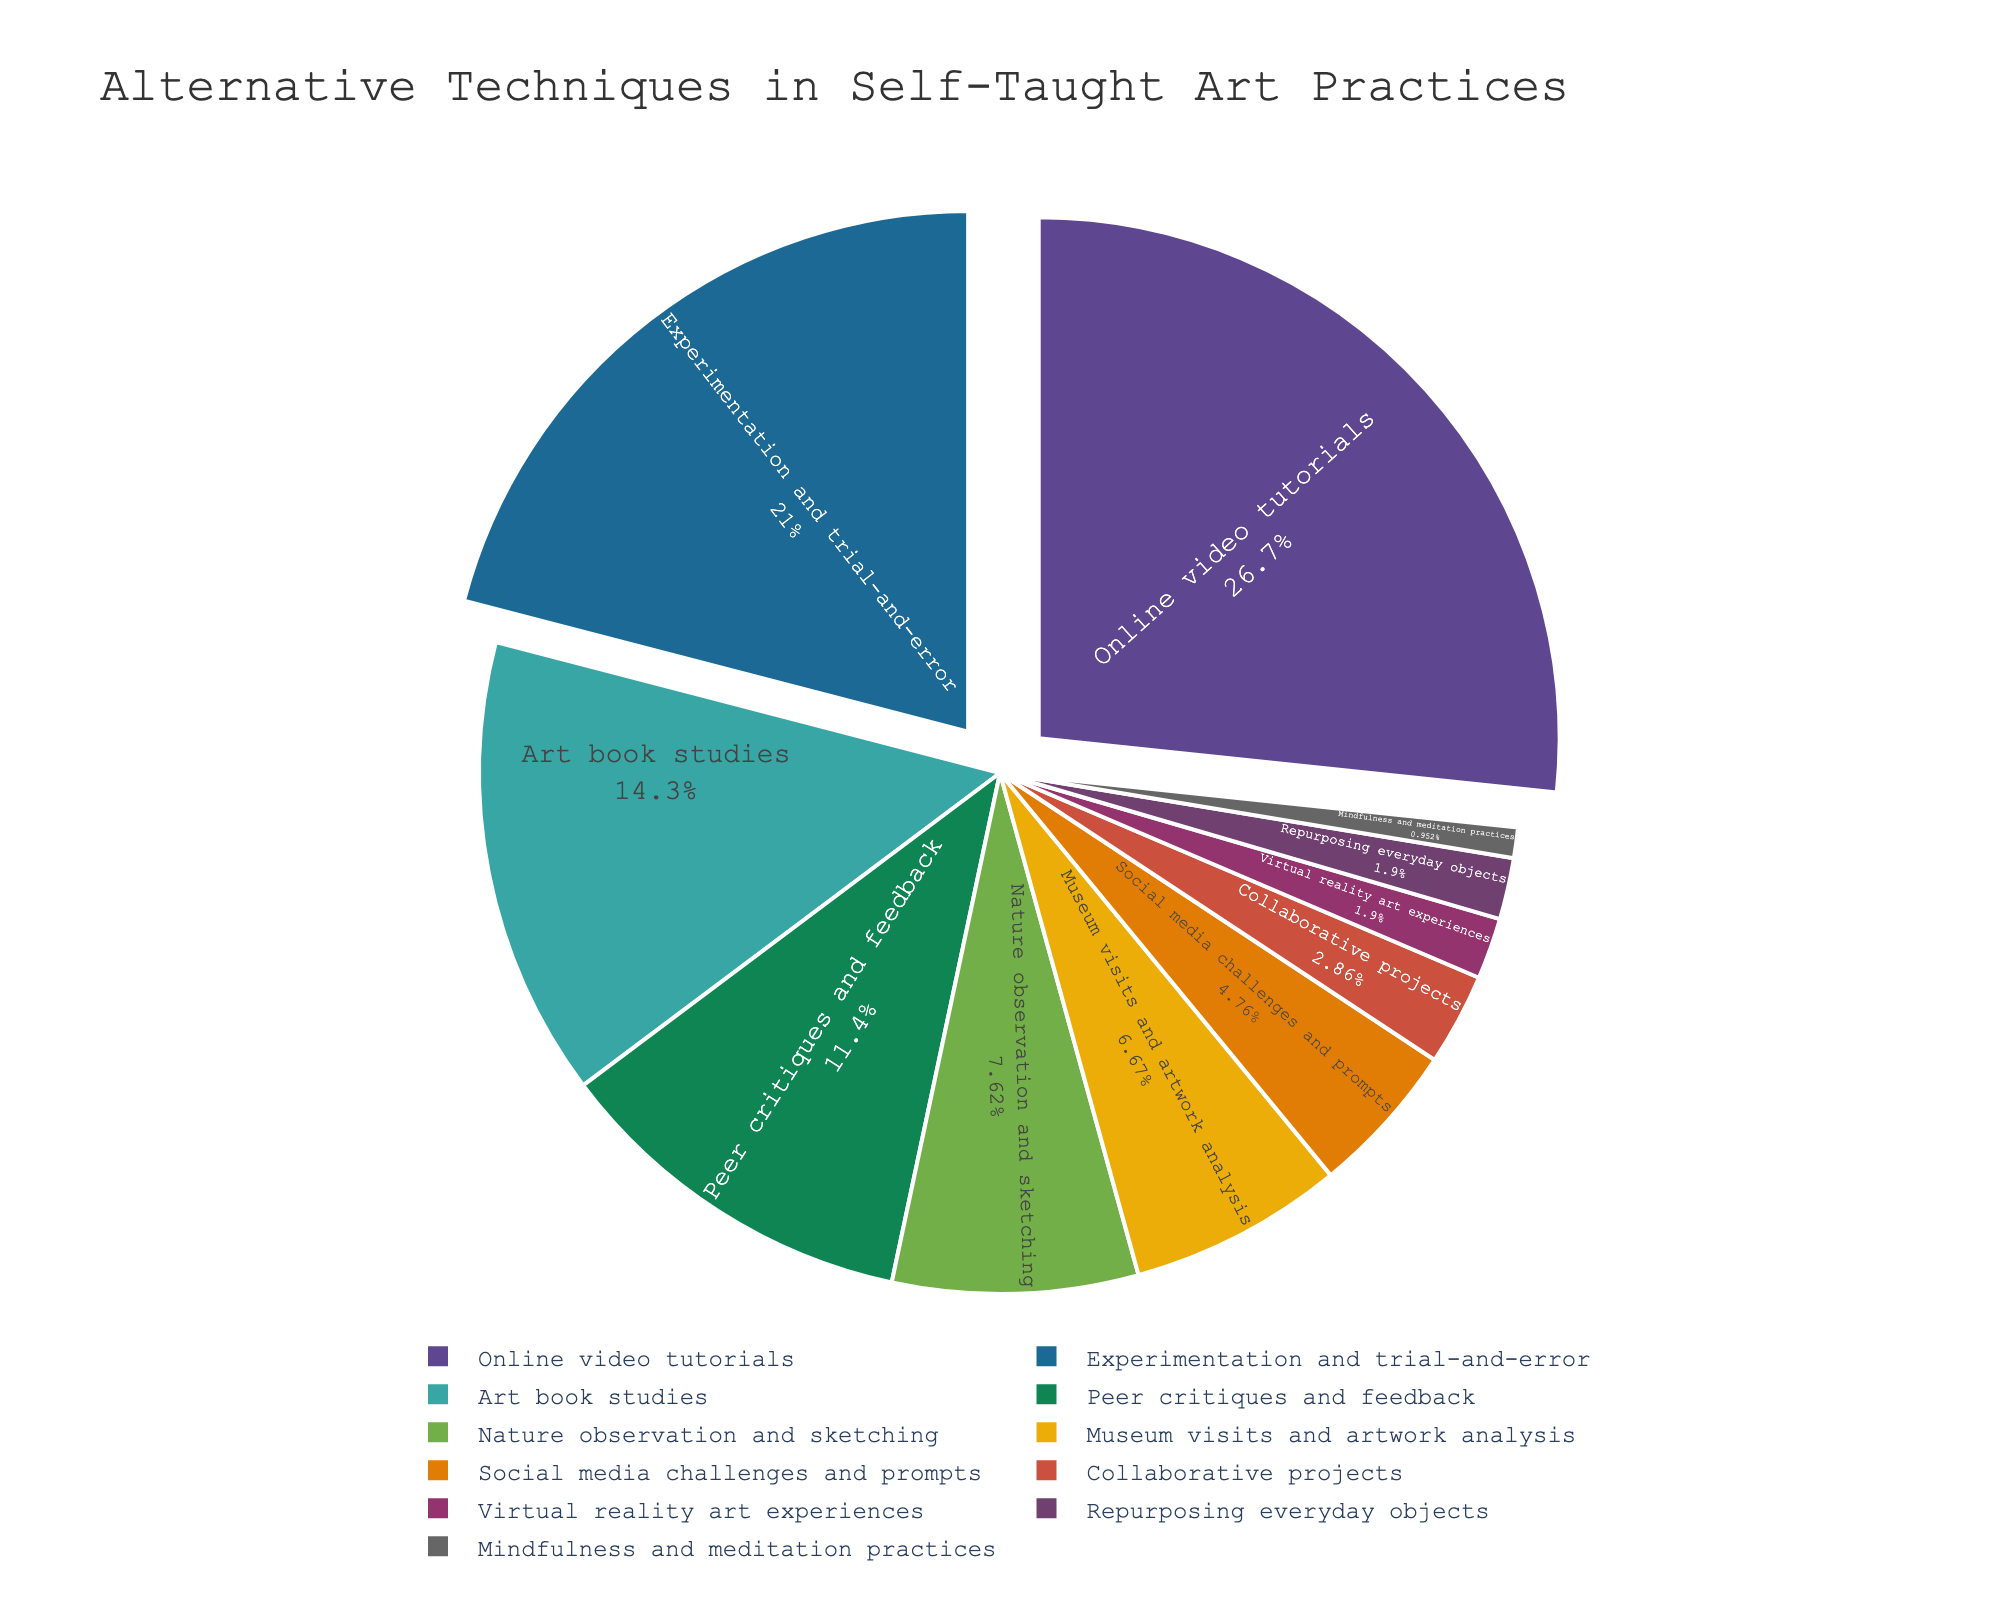what is the total percentage wrapped up by "Collaborative projects", "Virtual reality art experiences", and "Repurposing everyday objects"? Add the percentages of the three techniques: Collaborative projects (3%), Virtual reality art experiences (2%), and Repurposing everyday objects (2%). Therefore, the total percentage is 3 + 2 + 2 = 7%.
Answer: 7% Are there more percentages allocated to "Art book studies" or "Peer critiques and feedback"? Compare the percentages: Art book studies have 15%, while Peer critiques and feedback have 12%. Therefore, Art book studies have a higher percentage.
Answer: Art book studies What is the difference in percentages between "Nature observation and sketching" and "Museum visits and artwork analysis"? To find the difference, subtract the percentage of Museum visits and artwork analysis (7%) from Nature observation and sketching (8%). Thus, 8 - 7 = 1%.
Answer: 1% Which technique occupies the largest segment, and what is its percentage? The largest segment in the pie chart corresponds to Online video tutorials, which has a percentage of 28%.
Answer: Online video tutorials (28%) How much more popular are "Online video tutorials" compared to "Social media challenges and prompts"? Subtract the percentage of Social media challenges and prompts (5%) from Online video tutorials (28%). Therefore, 28 - 5 = 23%.
Answer: 23% What is the combined percentage of the top two techniques? The top two techniques are Online video tutorials (28%) and Experimentation and trial-and-error (22%). Add these percentages together to find the combined percentage: 28 + 22 = 50%.
Answer: 50% Which technique has the smallest percentage, and how much is it? The technique with the smallest percentage is Mindfulness and meditation practices, which has a percentage of 1%.
Answer: Mindfulness and meditation practices (1%) How much percentage is allocated to techniques involving direct interaction with other artists (Peer critiques and feedback + Collaborative projects)? Add the percentages of Peer critiques and feedback (12%) and Collaborative projects (3%). Therefore, the total percentage is 12 + 3 = 15%.
Answer: 15% If we group techniques with less than 5% into a single category, what percentage does this new category represent? Group techniques less than 5%: Social media challenges and prompts (5%), Collaborative projects (3%), Virtual reality art experiences (2%), Repurposing everyday objects (2%), and Mindfulness and meditation practices (1%). Add these percentages: 5 + 3 + 2 + 2 + 1 = 13%.
Answer: 13% What proportion of techniques involves some form of physical or nature-related practice (Nature observation and sketching + Museum visits and artwork analysis)? Add the percentages of Nature observation and sketching (8%) and Museum visits and artwork analysis (7%). Therefore, the total percentage is 8 + 7 = 15%.
Answer: 15% 